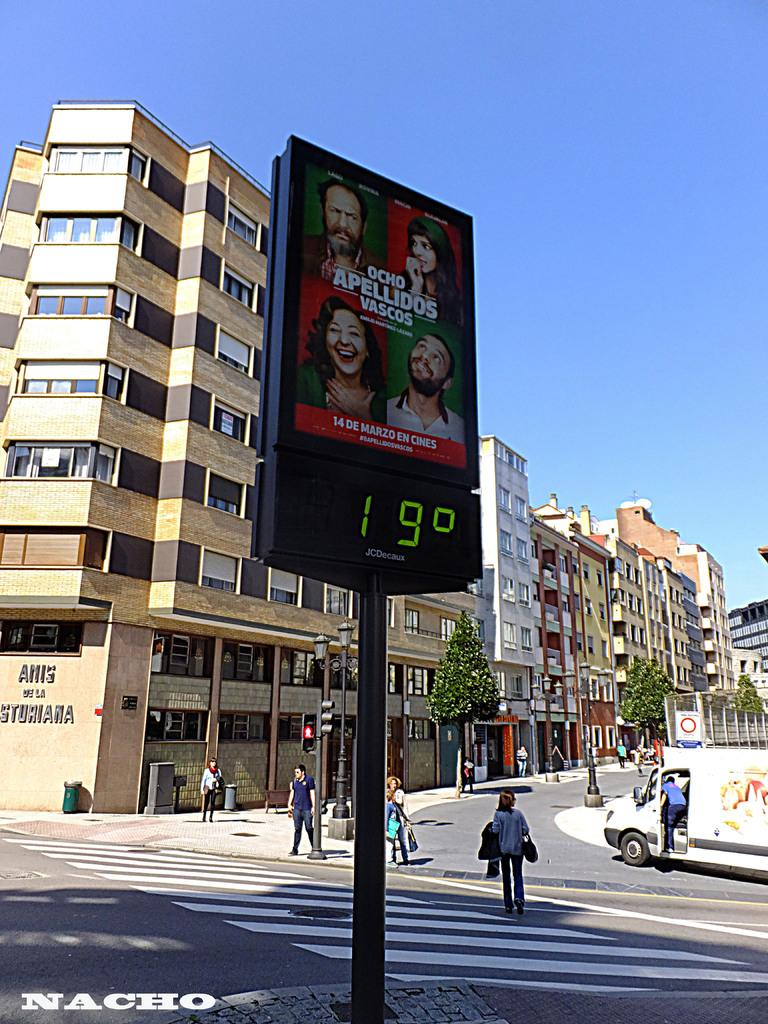<image>
Offer a succinct explanation of the picture presented. A warm cloudless day outside, with a temperature of 19c. 